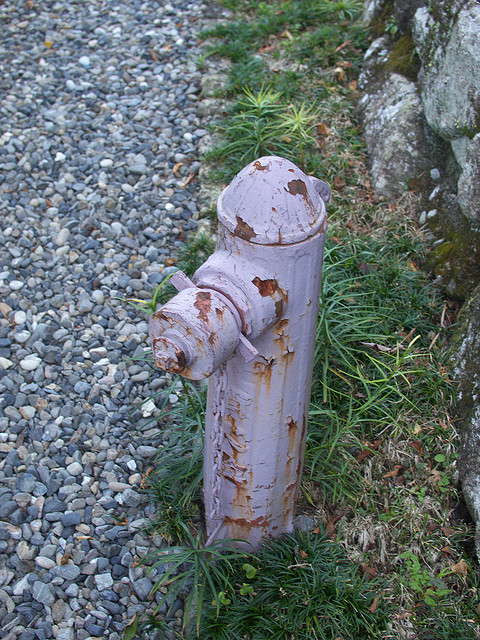If someone wanted to repaint it, what steps would they need to take? To repaint the fireplug, the following steps would be ideal:
1. Clean the surface thoroughly to remove dirt and debris.
2. Sand the fireplug to remove any loose or chipping paint and to create a smooth surface.
3. Apply a rust-inhibiting primer to prevent future corrosion.
4. Once the primer is dry, apply a few coats of durable, weather-resistant paint, allowing each coat to dry completely before applying the next.
5. Ensure proper ventilation and protective equipment during the painting process. 